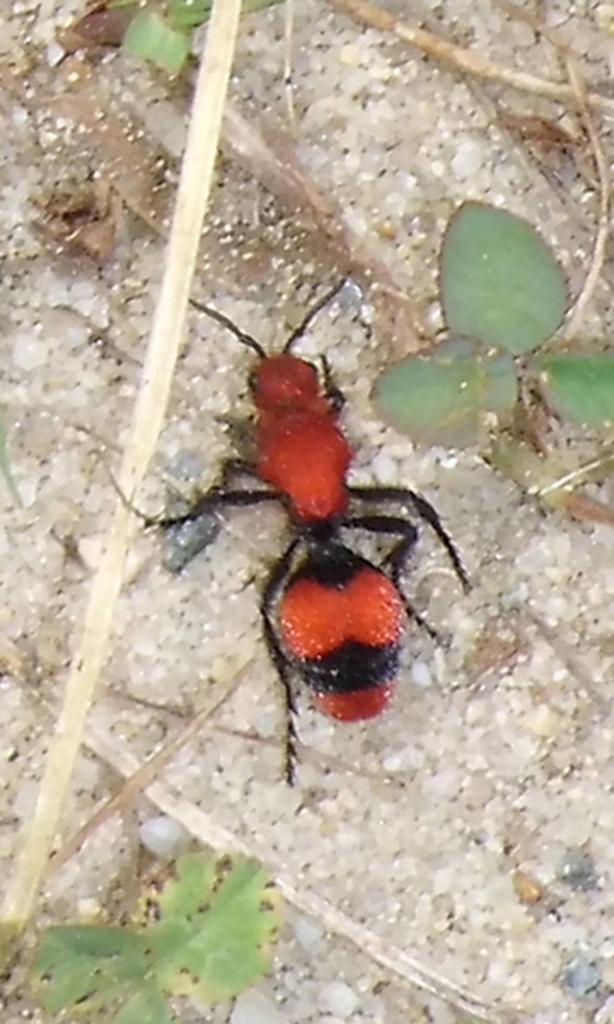Can you describe this image briefly? In this picture we can see an ant and plants on the ground. 